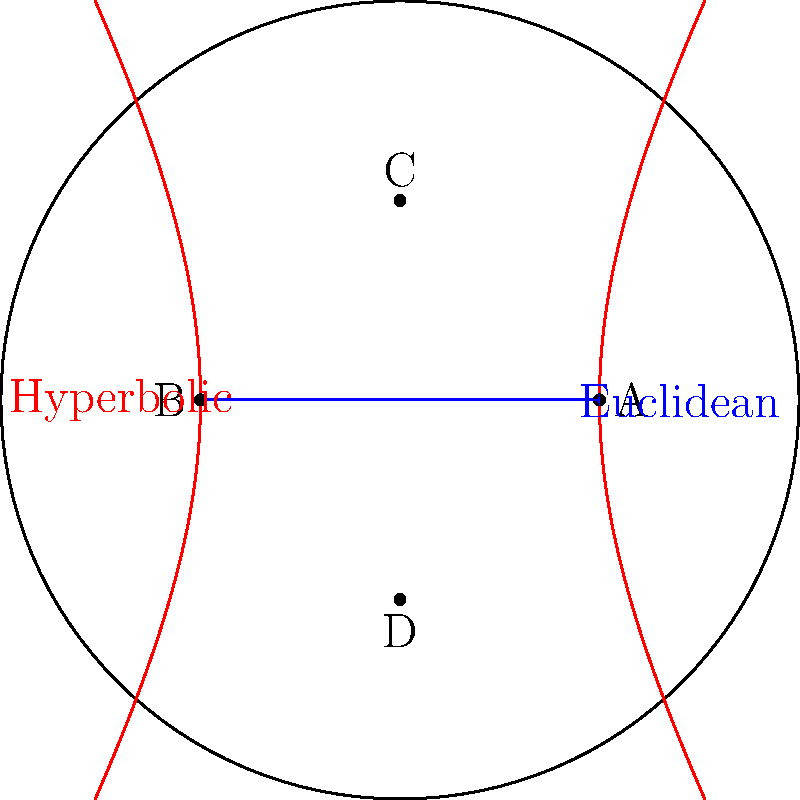In the Poincaré disk model of hyperbolic geometry shown above, the blue line represents a straight line in Euclidean geometry, while the red curve represents a straight line in hyperbolic geometry. Both pass through points A and B. Consider a line passing through points C and D. How many lines parallel to AB (in each geometry) can be drawn through point C? Let's approach this step-by-step:

1) In Euclidean geometry:
   - The parallel postulate states that through a point not on a given line, there is exactly one line parallel to the given line.
   - Therefore, through point C, there is exactly one line parallel to AB in Euclidean geometry.

2) In hyperbolic geometry (using the Poincaré disk model):
   - The parallel postulate does not hold in hyperbolic geometry.
   - In hyperbolic geometry, through a point not on a given line, there are infinitely many lines parallel to the given line.
   - In the Poincaré disk model, straight lines are represented by either:
     a) Diameters of the disk
     b) Circular arcs orthogonal to the boundary circle

3) Comparing the two:
   - In Euclidean geometry: 1 parallel line through C
   - In hyperbolic geometry: Infinitely many parallel lines through C

Therefore, there is a fundamental difference in the number of parallel lines that can be drawn through point C in these two geometries.
Answer: Euclidean: 1, Hyperbolic: $\infty$ (infinity) 